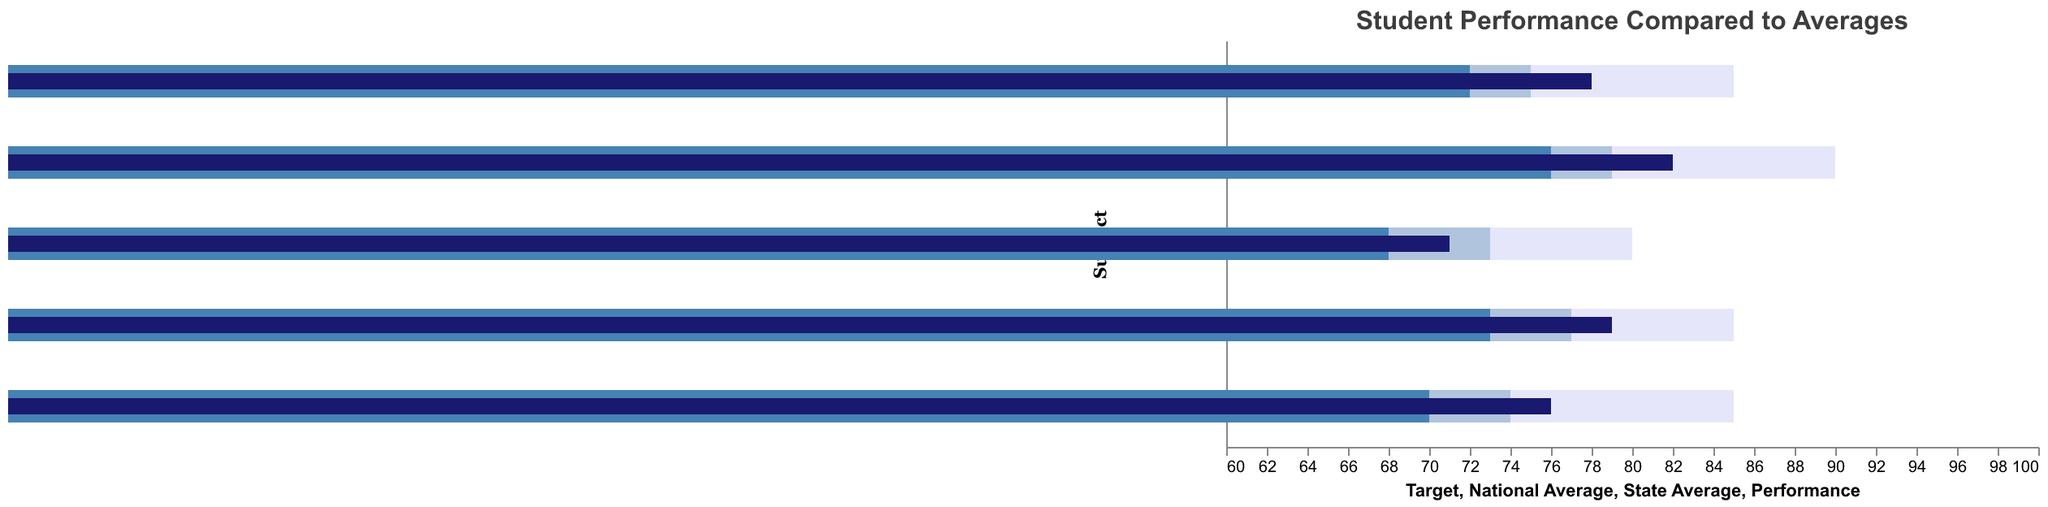What is the title of the chart? The title of the chart is displayed at the top and reads "Student Performance Compared to Averages."
Answer: Student Performance Compared to Averages What subject has the highest performance? To find the highest performance, look for the bar with the darkest color (which represents performance) that extends the farthest to the right. The subject "Reading" has the highest performance at 82.
Answer: Reading Which subjects have a performance above the national average? Compare the end of the performance bar for each subject with the national average bar (slightly lighter color). Subjects with performance exceeding the national average include Math (78 > 75), Reading (82 > 79), and Social Studies (79 > 77).
Answer: Math, Reading, Social Studies What subject is closest to meeting its target performance? To locate the closest performance to its target, compare the length of the performance bar with the target bar for each subject. Math has a performance of 78 and a target of 85, making it 7 points away, which is the smallest gap among all subjects.
Answer: Math How does student performance in Science compare to the state and national averages? For Science, the performance bar reaches 71. The state average bar reaches 68 and the national average bar reaches 73. This shows that the performance is above the state average but below the national average.
Answer: Above state average, Below national average In which subject is there the largest gap between performance and the target? Calculate the difference between the performance and target for each subject. Math: 85-78=7, Reading: 90-82=8, Science: 80-71=9, Writing: 85-76=9, Social Studies: 85-79=6. The largest gaps are in Science and Writing, both with a difference of 9 points.
Answer: Science, Writing Are there any subjects where the performance is both above the state and national averages? By comparing the performance bars with both the state and national average bars, the subjects where the performance is above both averages are Math (78 > 72 & 75), Reading (82 > 76 & 79), and Social Studies (79 > 73 & 77).
Answer: Math, Reading, Social Studies What is the range of state average scores across all subjects? To find the range, identify the highest and lowest state average scores. The highest state average score is for Reading (76) and the lowest is for Science (68). The range is 76 - 68.
Answer: 8 Which subject has the lowest performance compared to its target? Calculate the distance from the performance to the target for each subject and look for the largest gap. Science's target is 80 and its performance is 71. Therefore, the gap is 9, which is the largest gap compared to other subjects.
Answer: Science 